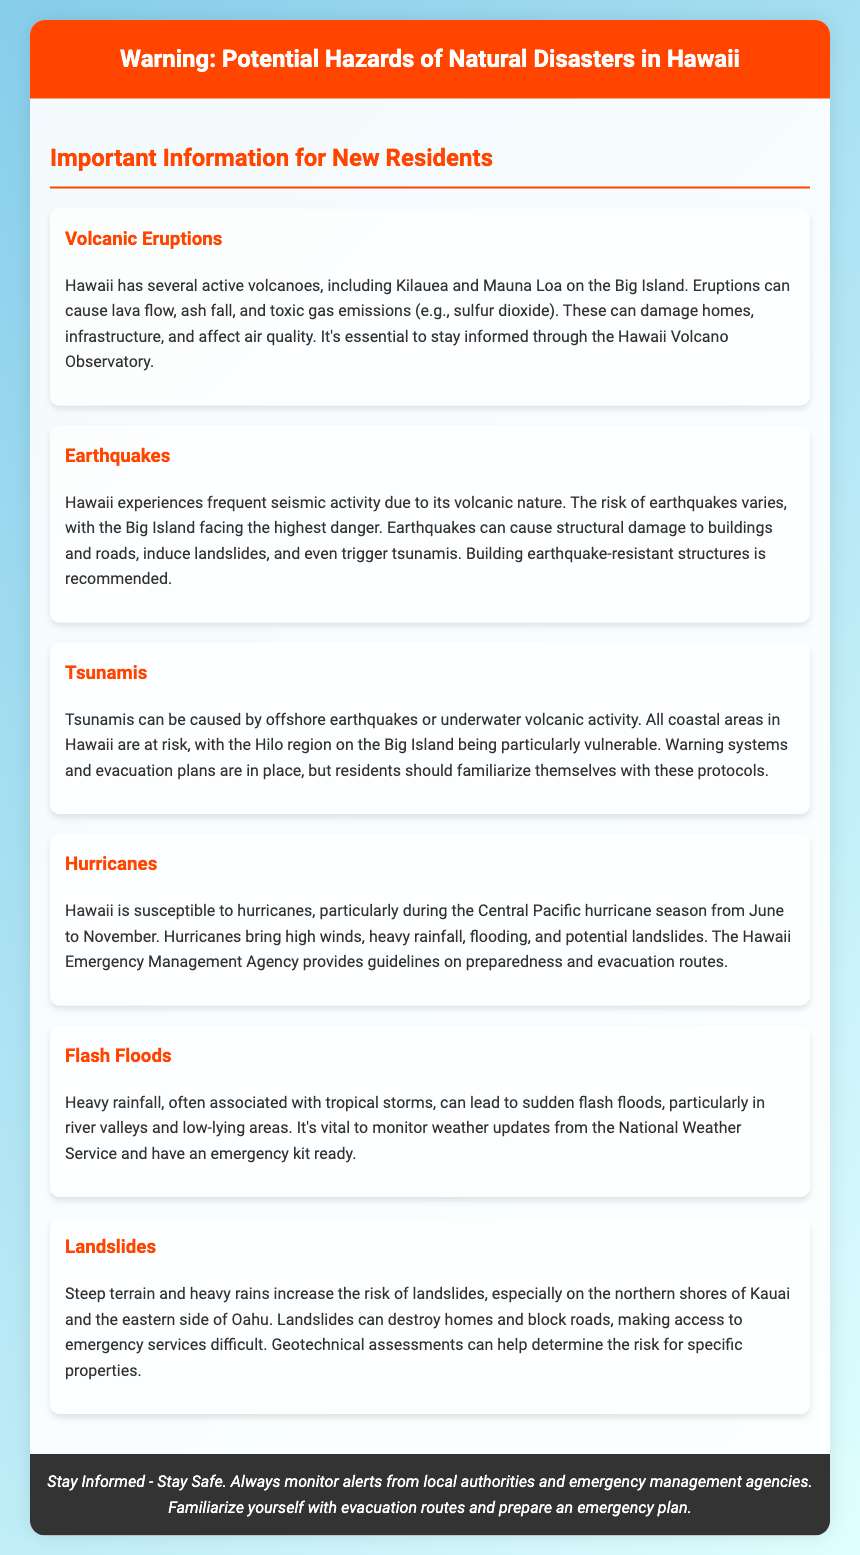What are the active volcanoes mentioned? The document lists Kilauea and Mauna Loa as active volcanoes in Hawaii.
Answer: Kilauea and Mauna Loa What should residents do during a volcanic eruption? Residents are advised to stay informed through the Hawaii Volcano Observatory during volcanic eruptions.
Answer: Stay informed through the Hawaii Volcano Observatory When is the hurricane season in Hawaii? The Central Pacific hurricane season spans from June to November according to the document.
Answer: June to November What natural disaster risk is highest on the Big Island? The document states that the Big Island faces the highest danger of earthquakes.
Answer: Earthquakes What can tsunamis be caused by? According to the document, tsunamis can be caused by offshore earthquakes or underwater volcanic activity.
Answer: Offshore earthquakes or underwater volcanic activity Which agency provides hurricane preparedness guidelines? The Hawaii Emergency Management Agency offers guidelines for hurricane preparedness as stated in the document.
Answer: Hawaii Emergency Management Agency Where is the Hilo region located? Hilo is specified in the document as being on the Big Island of Hawaii.
Answer: Big Island What increase the risk of landslides? The document mentions steep terrain and heavy rains as factors increasing the risk of landslides.
Answer: Steep terrain and heavy rains 